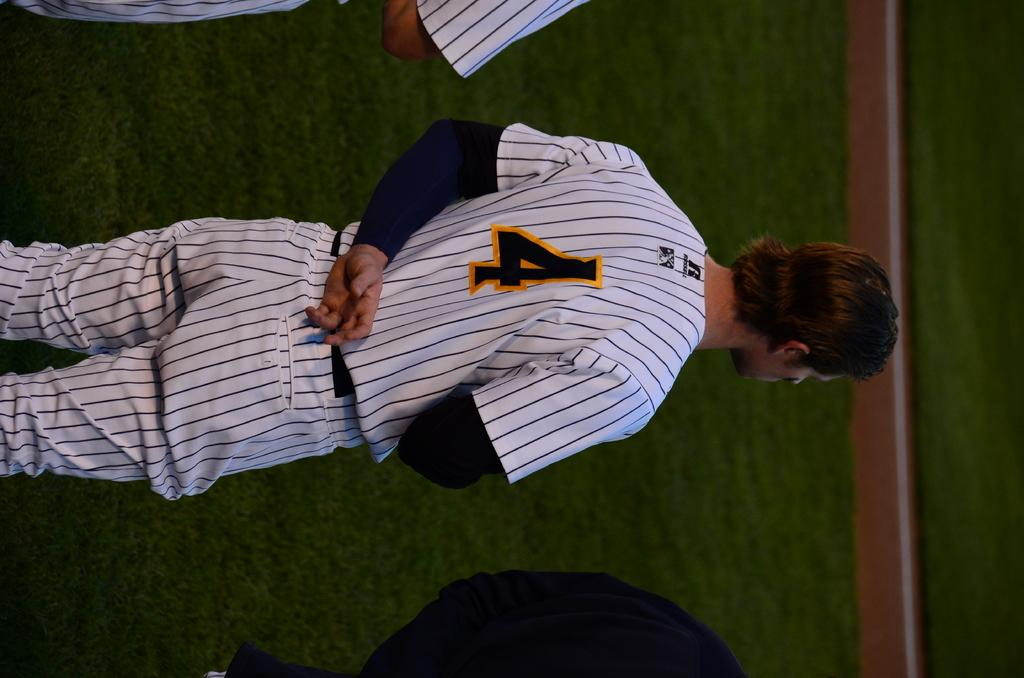Provide a one-sentence caption for the provided image. Man wearing a number 4 on his jersey standing with his arm behind his back. 